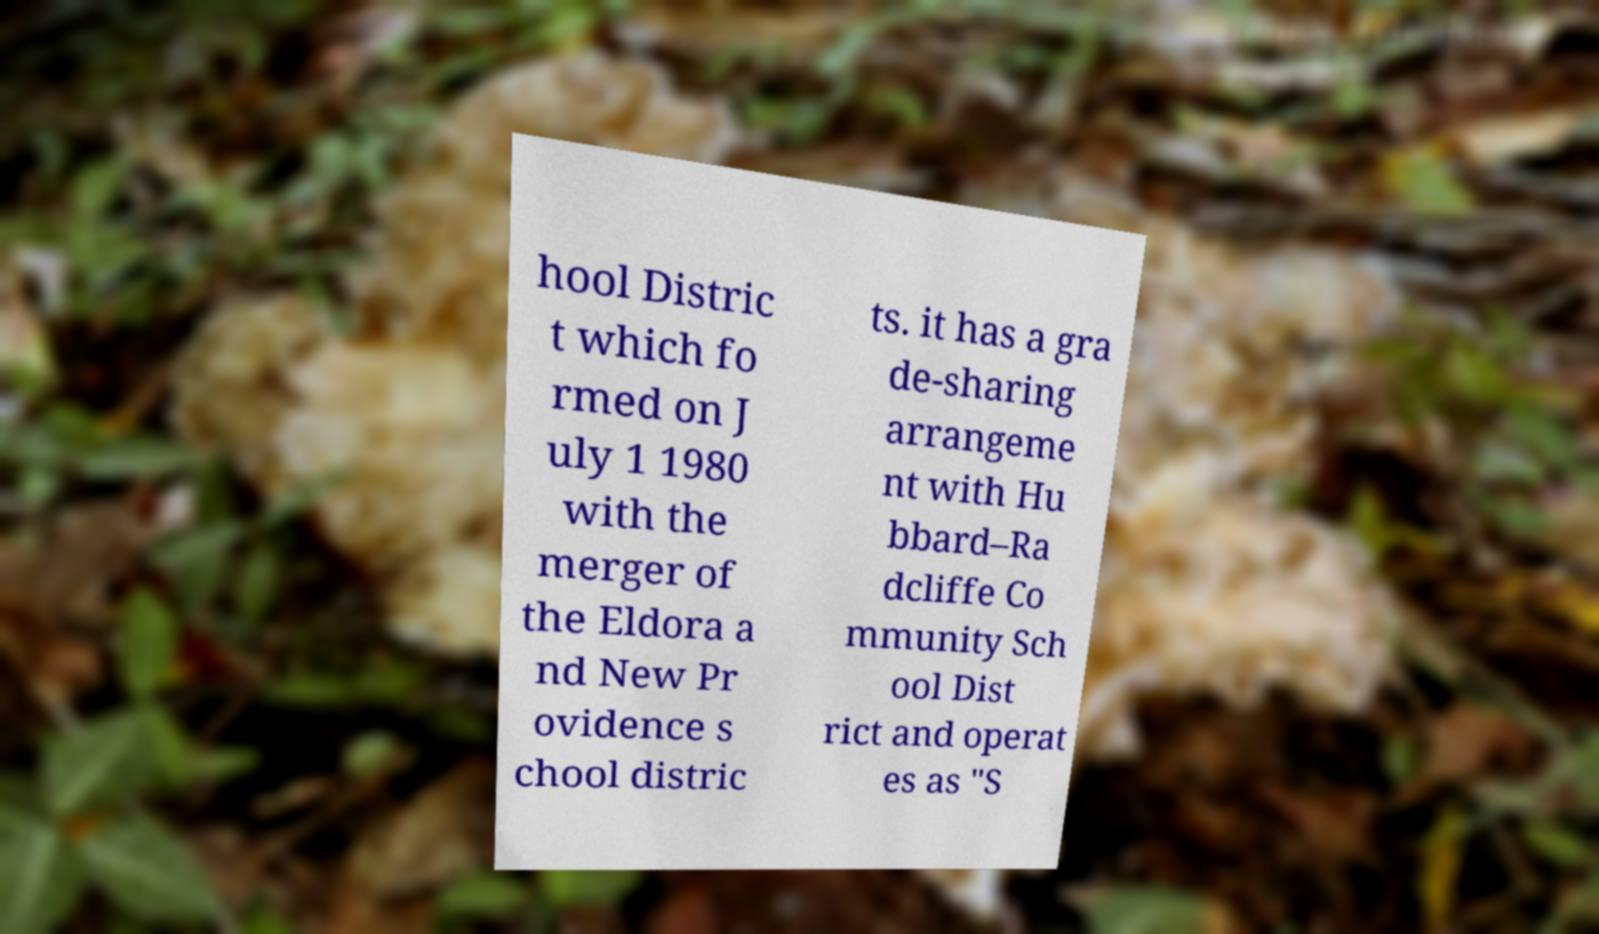Could you extract and type out the text from this image? hool Distric t which fo rmed on J uly 1 1980 with the merger of the Eldora a nd New Pr ovidence s chool distric ts. it has a gra de-sharing arrangeme nt with Hu bbard–Ra dcliffe Co mmunity Sch ool Dist rict and operat es as "S 